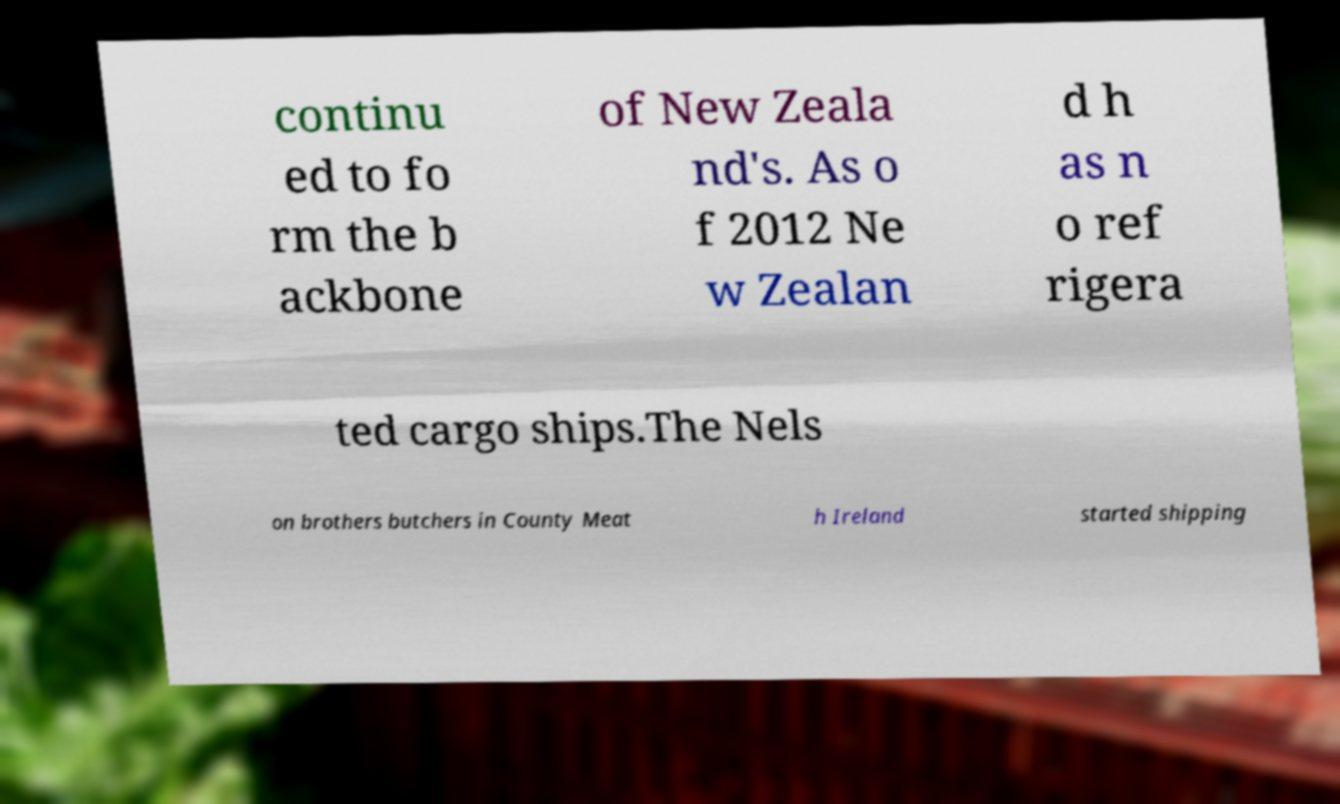Please read and relay the text visible in this image. What does it say? continu ed to fo rm the b ackbone of New Zeala nd's. As o f 2012 Ne w Zealan d h as n o ref rigera ted cargo ships.The Nels on brothers butchers in County Meat h Ireland started shipping 